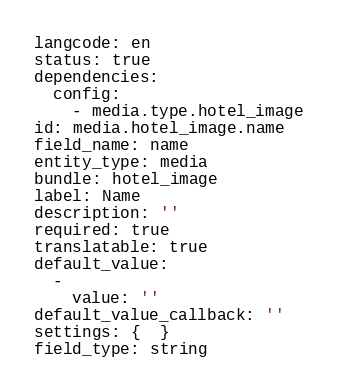Convert code to text. <code><loc_0><loc_0><loc_500><loc_500><_YAML_>langcode: en
status: true
dependencies:
  config:
    - media.type.hotel_image
id: media.hotel_image.name
field_name: name
entity_type: media
bundle: hotel_image
label: Name
description: ''
required: true
translatable: true
default_value:
  -
    value: ''
default_value_callback: ''
settings: {  }
field_type: string
</code> 